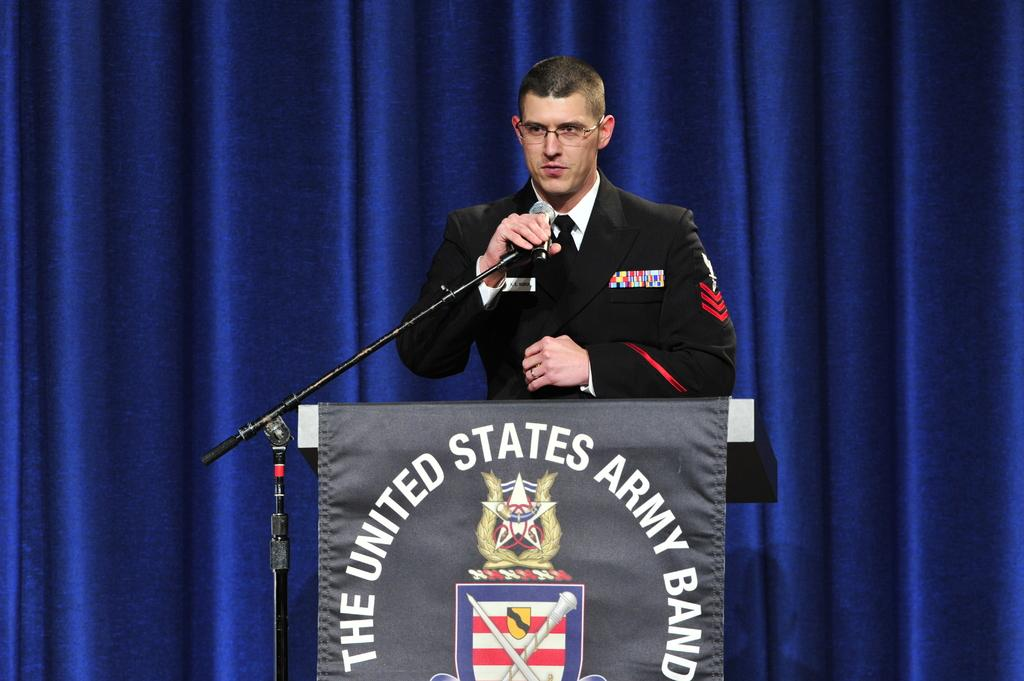What is the person in the image doing near the podium? The person is talking into a microphone. What can be seen in the background of the image? There is a blue color cloth in the background of the image. What type of sweater is the representative wearing in the image? There is no representative or sweater present in the image. 